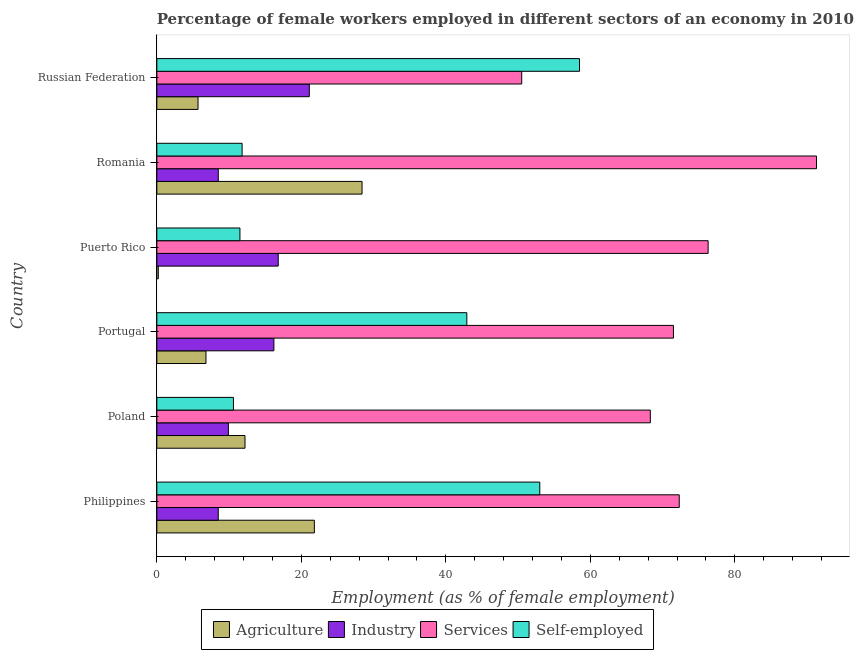How many different coloured bars are there?
Your response must be concise. 4. Are the number of bars on each tick of the Y-axis equal?
Offer a very short reply. Yes. How many bars are there on the 2nd tick from the top?
Offer a very short reply. 4. How many bars are there on the 5th tick from the bottom?
Ensure brevity in your answer.  4. What is the label of the 2nd group of bars from the top?
Keep it short and to the point. Romania. What is the percentage of female workers in services in Poland?
Provide a short and direct response. 68.3. Across all countries, what is the maximum percentage of female workers in agriculture?
Offer a very short reply. 28.4. Across all countries, what is the minimum percentage of female workers in agriculture?
Provide a succinct answer. 0.2. In which country was the percentage of self employed female workers maximum?
Keep it short and to the point. Russian Federation. What is the total percentage of female workers in services in the graph?
Offer a terse response. 430.2. What is the difference between the percentage of self employed female workers in Poland and the percentage of female workers in services in Portugal?
Offer a very short reply. -60.9. In how many countries, is the percentage of female workers in industry greater than 68 %?
Offer a very short reply. 0. What is the ratio of the percentage of female workers in agriculture in Portugal to that in Russian Federation?
Your response must be concise. 1.19. What is the difference between the highest and the lowest percentage of female workers in agriculture?
Offer a terse response. 28.2. In how many countries, is the percentage of self employed female workers greater than the average percentage of self employed female workers taken over all countries?
Your response must be concise. 3. What does the 2nd bar from the top in Philippines represents?
Keep it short and to the point. Services. What does the 4th bar from the bottom in Russian Federation represents?
Give a very brief answer. Self-employed. How many bars are there?
Your answer should be compact. 24. Are all the bars in the graph horizontal?
Offer a very short reply. Yes. Are the values on the major ticks of X-axis written in scientific E-notation?
Your answer should be very brief. No. Does the graph contain any zero values?
Your answer should be very brief. No. Where does the legend appear in the graph?
Keep it short and to the point. Bottom center. How are the legend labels stacked?
Provide a short and direct response. Horizontal. What is the title of the graph?
Your response must be concise. Percentage of female workers employed in different sectors of an economy in 2010. Does "Japan" appear as one of the legend labels in the graph?
Provide a short and direct response. No. What is the label or title of the X-axis?
Keep it short and to the point. Employment (as % of female employment). What is the Employment (as % of female employment) of Agriculture in Philippines?
Keep it short and to the point. 21.8. What is the Employment (as % of female employment) of Services in Philippines?
Keep it short and to the point. 72.3. What is the Employment (as % of female employment) of Self-employed in Philippines?
Make the answer very short. 53. What is the Employment (as % of female employment) of Agriculture in Poland?
Your answer should be compact. 12.2. What is the Employment (as % of female employment) in Industry in Poland?
Give a very brief answer. 9.9. What is the Employment (as % of female employment) in Services in Poland?
Provide a short and direct response. 68.3. What is the Employment (as % of female employment) in Self-employed in Poland?
Provide a succinct answer. 10.6. What is the Employment (as % of female employment) in Agriculture in Portugal?
Provide a short and direct response. 6.8. What is the Employment (as % of female employment) in Industry in Portugal?
Make the answer very short. 16.2. What is the Employment (as % of female employment) of Services in Portugal?
Provide a short and direct response. 71.5. What is the Employment (as % of female employment) in Self-employed in Portugal?
Give a very brief answer. 42.9. What is the Employment (as % of female employment) in Agriculture in Puerto Rico?
Provide a short and direct response. 0.2. What is the Employment (as % of female employment) of Industry in Puerto Rico?
Your response must be concise. 16.8. What is the Employment (as % of female employment) in Services in Puerto Rico?
Your answer should be compact. 76.3. What is the Employment (as % of female employment) in Self-employed in Puerto Rico?
Offer a very short reply. 11.5. What is the Employment (as % of female employment) in Agriculture in Romania?
Ensure brevity in your answer.  28.4. What is the Employment (as % of female employment) of Industry in Romania?
Your response must be concise. 8.5. What is the Employment (as % of female employment) in Services in Romania?
Keep it short and to the point. 91.3. What is the Employment (as % of female employment) of Self-employed in Romania?
Offer a very short reply. 11.8. What is the Employment (as % of female employment) of Agriculture in Russian Federation?
Provide a succinct answer. 5.7. What is the Employment (as % of female employment) in Industry in Russian Federation?
Make the answer very short. 21.1. What is the Employment (as % of female employment) of Services in Russian Federation?
Your answer should be compact. 50.5. What is the Employment (as % of female employment) of Self-employed in Russian Federation?
Provide a short and direct response. 58.5. Across all countries, what is the maximum Employment (as % of female employment) in Agriculture?
Your answer should be compact. 28.4. Across all countries, what is the maximum Employment (as % of female employment) of Industry?
Keep it short and to the point. 21.1. Across all countries, what is the maximum Employment (as % of female employment) of Services?
Ensure brevity in your answer.  91.3. Across all countries, what is the maximum Employment (as % of female employment) of Self-employed?
Offer a very short reply. 58.5. Across all countries, what is the minimum Employment (as % of female employment) of Agriculture?
Offer a terse response. 0.2. Across all countries, what is the minimum Employment (as % of female employment) of Services?
Keep it short and to the point. 50.5. Across all countries, what is the minimum Employment (as % of female employment) of Self-employed?
Keep it short and to the point. 10.6. What is the total Employment (as % of female employment) of Agriculture in the graph?
Your answer should be compact. 75.1. What is the total Employment (as % of female employment) in Industry in the graph?
Your response must be concise. 81. What is the total Employment (as % of female employment) of Services in the graph?
Make the answer very short. 430.2. What is the total Employment (as % of female employment) in Self-employed in the graph?
Ensure brevity in your answer.  188.3. What is the difference between the Employment (as % of female employment) of Agriculture in Philippines and that in Poland?
Provide a short and direct response. 9.6. What is the difference between the Employment (as % of female employment) in Self-employed in Philippines and that in Poland?
Give a very brief answer. 42.4. What is the difference between the Employment (as % of female employment) in Self-employed in Philippines and that in Portugal?
Provide a short and direct response. 10.1. What is the difference between the Employment (as % of female employment) of Agriculture in Philippines and that in Puerto Rico?
Your answer should be very brief. 21.6. What is the difference between the Employment (as % of female employment) in Industry in Philippines and that in Puerto Rico?
Offer a terse response. -8.3. What is the difference between the Employment (as % of female employment) of Services in Philippines and that in Puerto Rico?
Your response must be concise. -4. What is the difference between the Employment (as % of female employment) in Self-employed in Philippines and that in Puerto Rico?
Ensure brevity in your answer.  41.5. What is the difference between the Employment (as % of female employment) of Industry in Philippines and that in Romania?
Make the answer very short. 0. What is the difference between the Employment (as % of female employment) in Services in Philippines and that in Romania?
Keep it short and to the point. -19. What is the difference between the Employment (as % of female employment) in Self-employed in Philippines and that in Romania?
Your answer should be compact. 41.2. What is the difference between the Employment (as % of female employment) in Industry in Philippines and that in Russian Federation?
Offer a terse response. -12.6. What is the difference between the Employment (as % of female employment) in Services in Philippines and that in Russian Federation?
Offer a terse response. 21.8. What is the difference between the Employment (as % of female employment) in Self-employed in Philippines and that in Russian Federation?
Provide a short and direct response. -5.5. What is the difference between the Employment (as % of female employment) in Industry in Poland and that in Portugal?
Give a very brief answer. -6.3. What is the difference between the Employment (as % of female employment) of Services in Poland and that in Portugal?
Provide a short and direct response. -3.2. What is the difference between the Employment (as % of female employment) in Self-employed in Poland and that in Portugal?
Make the answer very short. -32.3. What is the difference between the Employment (as % of female employment) of Industry in Poland and that in Puerto Rico?
Provide a short and direct response. -6.9. What is the difference between the Employment (as % of female employment) of Self-employed in Poland and that in Puerto Rico?
Make the answer very short. -0.9. What is the difference between the Employment (as % of female employment) of Agriculture in Poland and that in Romania?
Offer a terse response. -16.2. What is the difference between the Employment (as % of female employment) in Industry in Poland and that in Romania?
Your response must be concise. 1.4. What is the difference between the Employment (as % of female employment) in Services in Poland and that in Russian Federation?
Offer a terse response. 17.8. What is the difference between the Employment (as % of female employment) of Self-employed in Poland and that in Russian Federation?
Your answer should be very brief. -47.9. What is the difference between the Employment (as % of female employment) of Industry in Portugal and that in Puerto Rico?
Offer a terse response. -0.6. What is the difference between the Employment (as % of female employment) in Services in Portugal and that in Puerto Rico?
Give a very brief answer. -4.8. What is the difference between the Employment (as % of female employment) of Self-employed in Portugal and that in Puerto Rico?
Ensure brevity in your answer.  31.4. What is the difference between the Employment (as % of female employment) in Agriculture in Portugal and that in Romania?
Provide a succinct answer. -21.6. What is the difference between the Employment (as % of female employment) in Industry in Portugal and that in Romania?
Provide a succinct answer. 7.7. What is the difference between the Employment (as % of female employment) of Services in Portugal and that in Romania?
Your response must be concise. -19.8. What is the difference between the Employment (as % of female employment) of Self-employed in Portugal and that in Romania?
Offer a very short reply. 31.1. What is the difference between the Employment (as % of female employment) of Agriculture in Portugal and that in Russian Federation?
Your answer should be very brief. 1.1. What is the difference between the Employment (as % of female employment) of Services in Portugal and that in Russian Federation?
Make the answer very short. 21. What is the difference between the Employment (as % of female employment) of Self-employed in Portugal and that in Russian Federation?
Give a very brief answer. -15.6. What is the difference between the Employment (as % of female employment) in Agriculture in Puerto Rico and that in Romania?
Give a very brief answer. -28.2. What is the difference between the Employment (as % of female employment) of Industry in Puerto Rico and that in Romania?
Offer a very short reply. 8.3. What is the difference between the Employment (as % of female employment) in Services in Puerto Rico and that in Romania?
Your answer should be very brief. -15. What is the difference between the Employment (as % of female employment) of Self-employed in Puerto Rico and that in Romania?
Your answer should be compact. -0.3. What is the difference between the Employment (as % of female employment) in Agriculture in Puerto Rico and that in Russian Federation?
Your answer should be compact. -5.5. What is the difference between the Employment (as % of female employment) in Industry in Puerto Rico and that in Russian Federation?
Provide a succinct answer. -4.3. What is the difference between the Employment (as % of female employment) in Services in Puerto Rico and that in Russian Federation?
Make the answer very short. 25.8. What is the difference between the Employment (as % of female employment) in Self-employed in Puerto Rico and that in Russian Federation?
Ensure brevity in your answer.  -47. What is the difference between the Employment (as % of female employment) of Agriculture in Romania and that in Russian Federation?
Offer a very short reply. 22.7. What is the difference between the Employment (as % of female employment) in Industry in Romania and that in Russian Federation?
Offer a terse response. -12.6. What is the difference between the Employment (as % of female employment) in Services in Romania and that in Russian Federation?
Ensure brevity in your answer.  40.8. What is the difference between the Employment (as % of female employment) of Self-employed in Romania and that in Russian Federation?
Make the answer very short. -46.7. What is the difference between the Employment (as % of female employment) of Agriculture in Philippines and the Employment (as % of female employment) of Services in Poland?
Make the answer very short. -46.5. What is the difference between the Employment (as % of female employment) of Agriculture in Philippines and the Employment (as % of female employment) of Self-employed in Poland?
Your response must be concise. 11.2. What is the difference between the Employment (as % of female employment) in Industry in Philippines and the Employment (as % of female employment) in Services in Poland?
Provide a succinct answer. -59.8. What is the difference between the Employment (as % of female employment) in Services in Philippines and the Employment (as % of female employment) in Self-employed in Poland?
Provide a succinct answer. 61.7. What is the difference between the Employment (as % of female employment) of Agriculture in Philippines and the Employment (as % of female employment) of Services in Portugal?
Offer a terse response. -49.7. What is the difference between the Employment (as % of female employment) in Agriculture in Philippines and the Employment (as % of female employment) in Self-employed in Portugal?
Offer a terse response. -21.1. What is the difference between the Employment (as % of female employment) of Industry in Philippines and the Employment (as % of female employment) of Services in Portugal?
Your answer should be very brief. -63. What is the difference between the Employment (as % of female employment) in Industry in Philippines and the Employment (as % of female employment) in Self-employed in Portugal?
Offer a very short reply. -34.4. What is the difference between the Employment (as % of female employment) in Services in Philippines and the Employment (as % of female employment) in Self-employed in Portugal?
Your answer should be very brief. 29.4. What is the difference between the Employment (as % of female employment) in Agriculture in Philippines and the Employment (as % of female employment) in Services in Puerto Rico?
Your response must be concise. -54.5. What is the difference between the Employment (as % of female employment) in Agriculture in Philippines and the Employment (as % of female employment) in Self-employed in Puerto Rico?
Your answer should be compact. 10.3. What is the difference between the Employment (as % of female employment) in Industry in Philippines and the Employment (as % of female employment) in Services in Puerto Rico?
Provide a succinct answer. -67.8. What is the difference between the Employment (as % of female employment) of Services in Philippines and the Employment (as % of female employment) of Self-employed in Puerto Rico?
Give a very brief answer. 60.8. What is the difference between the Employment (as % of female employment) in Agriculture in Philippines and the Employment (as % of female employment) in Services in Romania?
Your answer should be compact. -69.5. What is the difference between the Employment (as % of female employment) in Agriculture in Philippines and the Employment (as % of female employment) in Self-employed in Romania?
Keep it short and to the point. 10. What is the difference between the Employment (as % of female employment) of Industry in Philippines and the Employment (as % of female employment) of Services in Romania?
Give a very brief answer. -82.8. What is the difference between the Employment (as % of female employment) in Services in Philippines and the Employment (as % of female employment) in Self-employed in Romania?
Your answer should be very brief. 60.5. What is the difference between the Employment (as % of female employment) in Agriculture in Philippines and the Employment (as % of female employment) in Industry in Russian Federation?
Offer a very short reply. 0.7. What is the difference between the Employment (as % of female employment) of Agriculture in Philippines and the Employment (as % of female employment) of Services in Russian Federation?
Keep it short and to the point. -28.7. What is the difference between the Employment (as % of female employment) in Agriculture in Philippines and the Employment (as % of female employment) in Self-employed in Russian Federation?
Your answer should be compact. -36.7. What is the difference between the Employment (as % of female employment) in Industry in Philippines and the Employment (as % of female employment) in Services in Russian Federation?
Provide a succinct answer. -42. What is the difference between the Employment (as % of female employment) of Industry in Philippines and the Employment (as % of female employment) of Self-employed in Russian Federation?
Provide a succinct answer. -50. What is the difference between the Employment (as % of female employment) in Agriculture in Poland and the Employment (as % of female employment) in Industry in Portugal?
Make the answer very short. -4. What is the difference between the Employment (as % of female employment) in Agriculture in Poland and the Employment (as % of female employment) in Services in Portugal?
Provide a succinct answer. -59.3. What is the difference between the Employment (as % of female employment) in Agriculture in Poland and the Employment (as % of female employment) in Self-employed in Portugal?
Your answer should be very brief. -30.7. What is the difference between the Employment (as % of female employment) of Industry in Poland and the Employment (as % of female employment) of Services in Portugal?
Make the answer very short. -61.6. What is the difference between the Employment (as % of female employment) of Industry in Poland and the Employment (as % of female employment) of Self-employed in Portugal?
Offer a terse response. -33. What is the difference between the Employment (as % of female employment) of Services in Poland and the Employment (as % of female employment) of Self-employed in Portugal?
Your answer should be very brief. 25.4. What is the difference between the Employment (as % of female employment) of Agriculture in Poland and the Employment (as % of female employment) of Services in Puerto Rico?
Provide a short and direct response. -64.1. What is the difference between the Employment (as % of female employment) in Agriculture in Poland and the Employment (as % of female employment) in Self-employed in Puerto Rico?
Keep it short and to the point. 0.7. What is the difference between the Employment (as % of female employment) of Industry in Poland and the Employment (as % of female employment) of Services in Puerto Rico?
Your answer should be very brief. -66.4. What is the difference between the Employment (as % of female employment) of Services in Poland and the Employment (as % of female employment) of Self-employed in Puerto Rico?
Your answer should be compact. 56.8. What is the difference between the Employment (as % of female employment) in Agriculture in Poland and the Employment (as % of female employment) in Services in Romania?
Your response must be concise. -79.1. What is the difference between the Employment (as % of female employment) of Industry in Poland and the Employment (as % of female employment) of Services in Romania?
Offer a very short reply. -81.4. What is the difference between the Employment (as % of female employment) in Industry in Poland and the Employment (as % of female employment) in Self-employed in Romania?
Give a very brief answer. -1.9. What is the difference between the Employment (as % of female employment) in Services in Poland and the Employment (as % of female employment) in Self-employed in Romania?
Give a very brief answer. 56.5. What is the difference between the Employment (as % of female employment) in Agriculture in Poland and the Employment (as % of female employment) in Services in Russian Federation?
Keep it short and to the point. -38.3. What is the difference between the Employment (as % of female employment) in Agriculture in Poland and the Employment (as % of female employment) in Self-employed in Russian Federation?
Offer a terse response. -46.3. What is the difference between the Employment (as % of female employment) of Industry in Poland and the Employment (as % of female employment) of Services in Russian Federation?
Your response must be concise. -40.6. What is the difference between the Employment (as % of female employment) of Industry in Poland and the Employment (as % of female employment) of Self-employed in Russian Federation?
Your response must be concise. -48.6. What is the difference between the Employment (as % of female employment) in Agriculture in Portugal and the Employment (as % of female employment) in Industry in Puerto Rico?
Your answer should be very brief. -10. What is the difference between the Employment (as % of female employment) in Agriculture in Portugal and the Employment (as % of female employment) in Services in Puerto Rico?
Provide a short and direct response. -69.5. What is the difference between the Employment (as % of female employment) of Agriculture in Portugal and the Employment (as % of female employment) of Self-employed in Puerto Rico?
Provide a short and direct response. -4.7. What is the difference between the Employment (as % of female employment) in Industry in Portugal and the Employment (as % of female employment) in Services in Puerto Rico?
Provide a succinct answer. -60.1. What is the difference between the Employment (as % of female employment) of Services in Portugal and the Employment (as % of female employment) of Self-employed in Puerto Rico?
Provide a succinct answer. 60. What is the difference between the Employment (as % of female employment) in Agriculture in Portugal and the Employment (as % of female employment) in Industry in Romania?
Make the answer very short. -1.7. What is the difference between the Employment (as % of female employment) of Agriculture in Portugal and the Employment (as % of female employment) of Services in Romania?
Ensure brevity in your answer.  -84.5. What is the difference between the Employment (as % of female employment) in Agriculture in Portugal and the Employment (as % of female employment) in Self-employed in Romania?
Your answer should be compact. -5. What is the difference between the Employment (as % of female employment) in Industry in Portugal and the Employment (as % of female employment) in Services in Romania?
Ensure brevity in your answer.  -75.1. What is the difference between the Employment (as % of female employment) of Services in Portugal and the Employment (as % of female employment) of Self-employed in Romania?
Ensure brevity in your answer.  59.7. What is the difference between the Employment (as % of female employment) of Agriculture in Portugal and the Employment (as % of female employment) of Industry in Russian Federation?
Give a very brief answer. -14.3. What is the difference between the Employment (as % of female employment) of Agriculture in Portugal and the Employment (as % of female employment) of Services in Russian Federation?
Give a very brief answer. -43.7. What is the difference between the Employment (as % of female employment) of Agriculture in Portugal and the Employment (as % of female employment) of Self-employed in Russian Federation?
Give a very brief answer. -51.7. What is the difference between the Employment (as % of female employment) of Industry in Portugal and the Employment (as % of female employment) of Services in Russian Federation?
Make the answer very short. -34.3. What is the difference between the Employment (as % of female employment) in Industry in Portugal and the Employment (as % of female employment) in Self-employed in Russian Federation?
Your answer should be compact. -42.3. What is the difference between the Employment (as % of female employment) in Agriculture in Puerto Rico and the Employment (as % of female employment) in Services in Romania?
Offer a very short reply. -91.1. What is the difference between the Employment (as % of female employment) of Industry in Puerto Rico and the Employment (as % of female employment) of Services in Romania?
Keep it short and to the point. -74.5. What is the difference between the Employment (as % of female employment) of Services in Puerto Rico and the Employment (as % of female employment) of Self-employed in Romania?
Offer a very short reply. 64.5. What is the difference between the Employment (as % of female employment) in Agriculture in Puerto Rico and the Employment (as % of female employment) in Industry in Russian Federation?
Provide a succinct answer. -20.9. What is the difference between the Employment (as % of female employment) in Agriculture in Puerto Rico and the Employment (as % of female employment) in Services in Russian Federation?
Your answer should be compact. -50.3. What is the difference between the Employment (as % of female employment) of Agriculture in Puerto Rico and the Employment (as % of female employment) of Self-employed in Russian Federation?
Provide a short and direct response. -58.3. What is the difference between the Employment (as % of female employment) in Industry in Puerto Rico and the Employment (as % of female employment) in Services in Russian Federation?
Your response must be concise. -33.7. What is the difference between the Employment (as % of female employment) in Industry in Puerto Rico and the Employment (as % of female employment) in Self-employed in Russian Federation?
Your response must be concise. -41.7. What is the difference between the Employment (as % of female employment) of Services in Puerto Rico and the Employment (as % of female employment) of Self-employed in Russian Federation?
Offer a terse response. 17.8. What is the difference between the Employment (as % of female employment) in Agriculture in Romania and the Employment (as % of female employment) in Services in Russian Federation?
Your answer should be compact. -22.1. What is the difference between the Employment (as % of female employment) of Agriculture in Romania and the Employment (as % of female employment) of Self-employed in Russian Federation?
Keep it short and to the point. -30.1. What is the difference between the Employment (as % of female employment) in Industry in Romania and the Employment (as % of female employment) in Services in Russian Federation?
Provide a succinct answer. -42. What is the difference between the Employment (as % of female employment) in Services in Romania and the Employment (as % of female employment) in Self-employed in Russian Federation?
Your answer should be compact. 32.8. What is the average Employment (as % of female employment) of Agriculture per country?
Provide a short and direct response. 12.52. What is the average Employment (as % of female employment) of Services per country?
Offer a very short reply. 71.7. What is the average Employment (as % of female employment) in Self-employed per country?
Keep it short and to the point. 31.38. What is the difference between the Employment (as % of female employment) in Agriculture and Employment (as % of female employment) in Industry in Philippines?
Provide a short and direct response. 13.3. What is the difference between the Employment (as % of female employment) of Agriculture and Employment (as % of female employment) of Services in Philippines?
Make the answer very short. -50.5. What is the difference between the Employment (as % of female employment) in Agriculture and Employment (as % of female employment) in Self-employed in Philippines?
Ensure brevity in your answer.  -31.2. What is the difference between the Employment (as % of female employment) of Industry and Employment (as % of female employment) of Services in Philippines?
Ensure brevity in your answer.  -63.8. What is the difference between the Employment (as % of female employment) in Industry and Employment (as % of female employment) in Self-employed in Philippines?
Ensure brevity in your answer.  -44.5. What is the difference between the Employment (as % of female employment) of Services and Employment (as % of female employment) of Self-employed in Philippines?
Provide a succinct answer. 19.3. What is the difference between the Employment (as % of female employment) of Agriculture and Employment (as % of female employment) of Services in Poland?
Give a very brief answer. -56.1. What is the difference between the Employment (as % of female employment) of Agriculture and Employment (as % of female employment) of Self-employed in Poland?
Ensure brevity in your answer.  1.6. What is the difference between the Employment (as % of female employment) of Industry and Employment (as % of female employment) of Services in Poland?
Provide a succinct answer. -58.4. What is the difference between the Employment (as % of female employment) of Industry and Employment (as % of female employment) of Self-employed in Poland?
Your answer should be very brief. -0.7. What is the difference between the Employment (as % of female employment) in Services and Employment (as % of female employment) in Self-employed in Poland?
Ensure brevity in your answer.  57.7. What is the difference between the Employment (as % of female employment) in Agriculture and Employment (as % of female employment) in Industry in Portugal?
Keep it short and to the point. -9.4. What is the difference between the Employment (as % of female employment) in Agriculture and Employment (as % of female employment) in Services in Portugal?
Provide a succinct answer. -64.7. What is the difference between the Employment (as % of female employment) of Agriculture and Employment (as % of female employment) of Self-employed in Portugal?
Offer a terse response. -36.1. What is the difference between the Employment (as % of female employment) in Industry and Employment (as % of female employment) in Services in Portugal?
Keep it short and to the point. -55.3. What is the difference between the Employment (as % of female employment) of Industry and Employment (as % of female employment) of Self-employed in Portugal?
Provide a short and direct response. -26.7. What is the difference between the Employment (as % of female employment) in Services and Employment (as % of female employment) in Self-employed in Portugal?
Provide a succinct answer. 28.6. What is the difference between the Employment (as % of female employment) of Agriculture and Employment (as % of female employment) of Industry in Puerto Rico?
Provide a short and direct response. -16.6. What is the difference between the Employment (as % of female employment) in Agriculture and Employment (as % of female employment) in Services in Puerto Rico?
Offer a terse response. -76.1. What is the difference between the Employment (as % of female employment) in Agriculture and Employment (as % of female employment) in Self-employed in Puerto Rico?
Give a very brief answer. -11.3. What is the difference between the Employment (as % of female employment) of Industry and Employment (as % of female employment) of Services in Puerto Rico?
Ensure brevity in your answer.  -59.5. What is the difference between the Employment (as % of female employment) of Services and Employment (as % of female employment) of Self-employed in Puerto Rico?
Offer a very short reply. 64.8. What is the difference between the Employment (as % of female employment) in Agriculture and Employment (as % of female employment) in Services in Romania?
Give a very brief answer. -62.9. What is the difference between the Employment (as % of female employment) in Agriculture and Employment (as % of female employment) in Self-employed in Romania?
Provide a succinct answer. 16.6. What is the difference between the Employment (as % of female employment) of Industry and Employment (as % of female employment) of Services in Romania?
Provide a short and direct response. -82.8. What is the difference between the Employment (as % of female employment) of Industry and Employment (as % of female employment) of Self-employed in Romania?
Provide a short and direct response. -3.3. What is the difference between the Employment (as % of female employment) of Services and Employment (as % of female employment) of Self-employed in Romania?
Your response must be concise. 79.5. What is the difference between the Employment (as % of female employment) of Agriculture and Employment (as % of female employment) of Industry in Russian Federation?
Ensure brevity in your answer.  -15.4. What is the difference between the Employment (as % of female employment) in Agriculture and Employment (as % of female employment) in Services in Russian Federation?
Your answer should be very brief. -44.8. What is the difference between the Employment (as % of female employment) in Agriculture and Employment (as % of female employment) in Self-employed in Russian Federation?
Your answer should be very brief. -52.8. What is the difference between the Employment (as % of female employment) in Industry and Employment (as % of female employment) in Services in Russian Federation?
Offer a terse response. -29.4. What is the difference between the Employment (as % of female employment) in Industry and Employment (as % of female employment) in Self-employed in Russian Federation?
Provide a succinct answer. -37.4. What is the difference between the Employment (as % of female employment) in Services and Employment (as % of female employment) in Self-employed in Russian Federation?
Your answer should be compact. -8. What is the ratio of the Employment (as % of female employment) in Agriculture in Philippines to that in Poland?
Make the answer very short. 1.79. What is the ratio of the Employment (as % of female employment) in Industry in Philippines to that in Poland?
Offer a very short reply. 0.86. What is the ratio of the Employment (as % of female employment) in Services in Philippines to that in Poland?
Provide a succinct answer. 1.06. What is the ratio of the Employment (as % of female employment) in Self-employed in Philippines to that in Poland?
Offer a very short reply. 5. What is the ratio of the Employment (as % of female employment) of Agriculture in Philippines to that in Portugal?
Your answer should be compact. 3.21. What is the ratio of the Employment (as % of female employment) in Industry in Philippines to that in Portugal?
Ensure brevity in your answer.  0.52. What is the ratio of the Employment (as % of female employment) in Services in Philippines to that in Portugal?
Give a very brief answer. 1.01. What is the ratio of the Employment (as % of female employment) of Self-employed in Philippines to that in Portugal?
Give a very brief answer. 1.24. What is the ratio of the Employment (as % of female employment) of Agriculture in Philippines to that in Puerto Rico?
Keep it short and to the point. 109. What is the ratio of the Employment (as % of female employment) in Industry in Philippines to that in Puerto Rico?
Keep it short and to the point. 0.51. What is the ratio of the Employment (as % of female employment) in Services in Philippines to that in Puerto Rico?
Your answer should be very brief. 0.95. What is the ratio of the Employment (as % of female employment) in Self-employed in Philippines to that in Puerto Rico?
Your response must be concise. 4.61. What is the ratio of the Employment (as % of female employment) of Agriculture in Philippines to that in Romania?
Make the answer very short. 0.77. What is the ratio of the Employment (as % of female employment) in Industry in Philippines to that in Romania?
Your response must be concise. 1. What is the ratio of the Employment (as % of female employment) in Services in Philippines to that in Romania?
Your answer should be very brief. 0.79. What is the ratio of the Employment (as % of female employment) of Self-employed in Philippines to that in Romania?
Make the answer very short. 4.49. What is the ratio of the Employment (as % of female employment) in Agriculture in Philippines to that in Russian Federation?
Offer a terse response. 3.82. What is the ratio of the Employment (as % of female employment) of Industry in Philippines to that in Russian Federation?
Make the answer very short. 0.4. What is the ratio of the Employment (as % of female employment) in Services in Philippines to that in Russian Federation?
Ensure brevity in your answer.  1.43. What is the ratio of the Employment (as % of female employment) of Self-employed in Philippines to that in Russian Federation?
Your answer should be compact. 0.91. What is the ratio of the Employment (as % of female employment) in Agriculture in Poland to that in Portugal?
Provide a short and direct response. 1.79. What is the ratio of the Employment (as % of female employment) of Industry in Poland to that in Portugal?
Provide a succinct answer. 0.61. What is the ratio of the Employment (as % of female employment) in Services in Poland to that in Portugal?
Your answer should be very brief. 0.96. What is the ratio of the Employment (as % of female employment) in Self-employed in Poland to that in Portugal?
Offer a very short reply. 0.25. What is the ratio of the Employment (as % of female employment) of Industry in Poland to that in Puerto Rico?
Your answer should be very brief. 0.59. What is the ratio of the Employment (as % of female employment) in Services in Poland to that in Puerto Rico?
Your answer should be very brief. 0.9. What is the ratio of the Employment (as % of female employment) in Self-employed in Poland to that in Puerto Rico?
Your answer should be very brief. 0.92. What is the ratio of the Employment (as % of female employment) in Agriculture in Poland to that in Romania?
Provide a short and direct response. 0.43. What is the ratio of the Employment (as % of female employment) in Industry in Poland to that in Romania?
Offer a very short reply. 1.16. What is the ratio of the Employment (as % of female employment) of Services in Poland to that in Romania?
Make the answer very short. 0.75. What is the ratio of the Employment (as % of female employment) in Self-employed in Poland to that in Romania?
Provide a succinct answer. 0.9. What is the ratio of the Employment (as % of female employment) of Agriculture in Poland to that in Russian Federation?
Offer a terse response. 2.14. What is the ratio of the Employment (as % of female employment) of Industry in Poland to that in Russian Federation?
Keep it short and to the point. 0.47. What is the ratio of the Employment (as % of female employment) of Services in Poland to that in Russian Federation?
Make the answer very short. 1.35. What is the ratio of the Employment (as % of female employment) in Self-employed in Poland to that in Russian Federation?
Provide a short and direct response. 0.18. What is the ratio of the Employment (as % of female employment) of Industry in Portugal to that in Puerto Rico?
Your response must be concise. 0.96. What is the ratio of the Employment (as % of female employment) of Services in Portugal to that in Puerto Rico?
Keep it short and to the point. 0.94. What is the ratio of the Employment (as % of female employment) of Self-employed in Portugal to that in Puerto Rico?
Make the answer very short. 3.73. What is the ratio of the Employment (as % of female employment) in Agriculture in Portugal to that in Romania?
Your response must be concise. 0.24. What is the ratio of the Employment (as % of female employment) of Industry in Portugal to that in Romania?
Give a very brief answer. 1.91. What is the ratio of the Employment (as % of female employment) of Services in Portugal to that in Romania?
Your response must be concise. 0.78. What is the ratio of the Employment (as % of female employment) in Self-employed in Portugal to that in Romania?
Your answer should be very brief. 3.64. What is the ratio of the Employment (as % of female employment) of Agriculture in Portugal to that in Russian Federation?
Your answer should be compact. 1.19. What is the ratio of the Employment (as % of female employment) in Industry in Portugal to that in Russian Federation?
Your answer should be very brief. 0.77. What is the ratio of the Employment (as % of female employment) in Services in Portugal to that in Russian Federation?
Offer a very short reply. 1.42. What is the ratio of the Employment (as % of female employment) of Self-employed in Portugal to that in Russian Federation?
Make the answer very short. 0.73. What is the ratio of the Employment (as % of female employment) of Agriculture in Puerto Rico to that in Romania?
Offer a terse response. 0.01. What is the ratio of the Employment (as % of female employment) of Industry in Puerto Rico to that in Romania?
Provide a short and direct response. 1.98. What is the ratio of the Employment (as % of female employment) in Services in Puerto Rico to that in Romania?
Give a very brief answer. 0.84. What is the ratio of the Employment (as % of female employment) of Self-employed in Puerto Rico to that in Romania?
Your response must be concise. 0.97. What is the ratio of the Employment (as % of female employment) in Agriculture in Puerto Rico to that in Russian Federation?
Provide a succinct answer. 0.04. What is the ratio of the Employment (as % of female employment) of Industry in Puerto Rico to that in Russian Federation?
Offer a terse response. 0.8. What is the ratio of the Employment (as % of female employment) in Services in Puerto Rico to that in Russian Federation?
Give a very brief answer. 1.51. What is the ratio of the Employment (as % of female employment) in Self-employed in Puerto Rico to that in Russian Federation?
Offer a very short reply. 0.2. What is the ratio of the Employment (as % of female employment) of Agriculture in Romania to that in Russian Federation?
Give a very brief answer. 4.98. What is the ratio of the Employment (as % of female employment) in Industry in Romania to that in Russian Federation?
Keep it short and to the point. 0.4. What is the ratio of the Employment (as % of female employment) in Services in Romania to that in Russian Federation?
Offer a very short reply. 1.81. What is the ratio of the Employment (as % of female employment) of Self-employed in Romania to that in Russian Federation?
Keep it short and to the point. 0.2. What is the difference between the highest and the second highest Employment (as % of female employment) in Services?
Provide a short and direct response. 15. What is the difference between the highest and the second highest Employment (as % of female employment) in Self-employed?
Your answer should be compact. 5.5. What is the difference between the highest and the lowest Employment (as % of female employment) of Agriculture?
Provide a succinct answer. 28.2. What is the difference between the highest and the lowest Employment (as % of female employment) in Industry?
Give a very brief answer. 12.6. What is the difference between the highest and the lowest Employment (as % of female employment) of Services?
Keep it short and to the point. 40.8. What is the difference between the highest and the lowest Employment (as % of female employment) of Self-employed?
Provide a succinct answer. 47.9. 